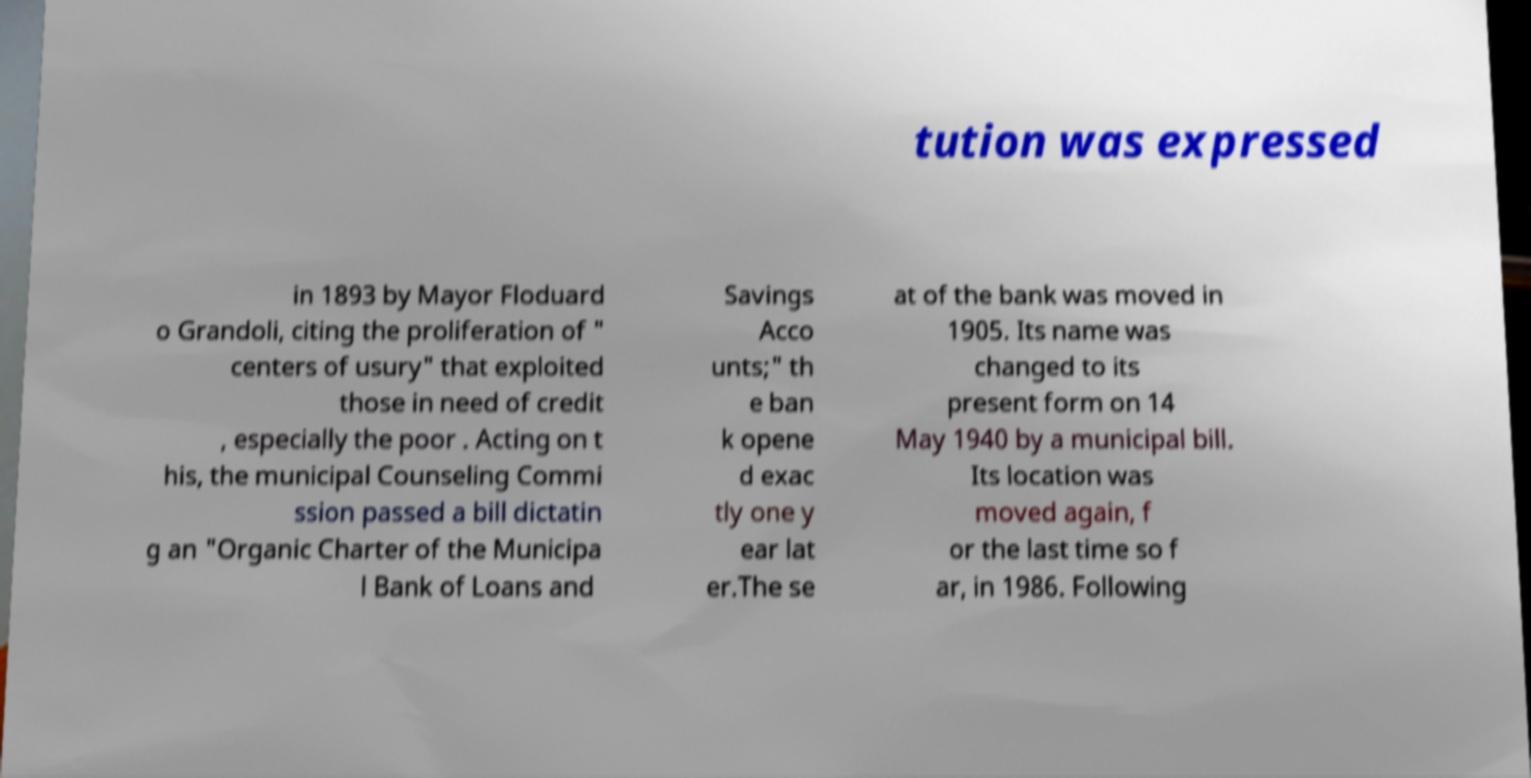For documentation purposes, I need the text within this image transcribed. Could you provide that? tution was expressed in 1893 by Mayor Floduard o Grandoli, citing the proliferation of " centers of usury" that exploited those in need of credit , especially the poor . Acting on t his, the municipal Counseling Commi ssion passed a bill dictatin g an "Organic Charter of the Municipa l Bank of Loans and Savings Acco unts;" th e ban k opene d exac tly one y ear lat er.The se at of the bank was moved in 1905. Its name was changed to its present form on 14 May 1940 by a municipal bill. Its location was moved again, f or the last time so f ar, in 1986. Following 